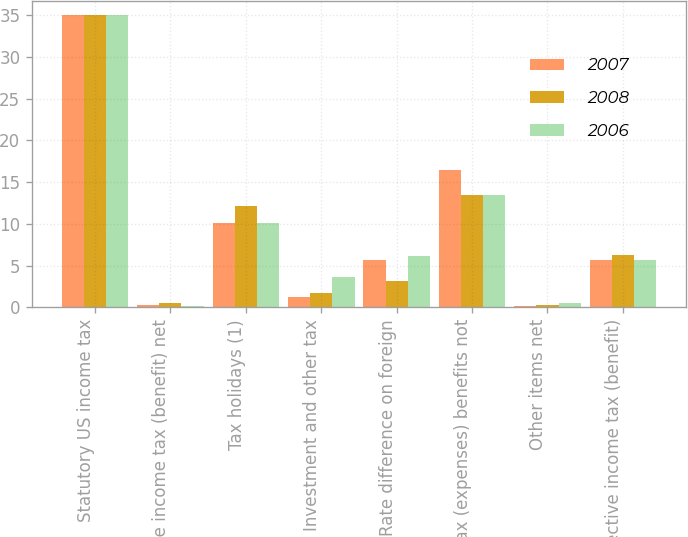Convert chart. <chart><loc_0><loc_0><loc_500><loc_500><stacked_bar_chart><ecel><fcel>Statutory US income tax<fcel>State income tax (benefit) net<fcel>Tax holidays (1)<fcel>Investment and other tax<fcel>Rate difference on foreign<fcel>Tax (expenses) benefits not<fcel>Other items net<fcel>Effective income tax (benefit)<nl><fcel>2007<fcel>35<fcel>0.3<fcel>10.1<fcel>1.2<fcel>5.7<fcel>16.5<fcel>0.1<fcel>5.7<nl><fcel>2008<fcel>35<fcel>0.5<fcel>12.1<fcel>1.7<fcel>3.1<fcel>13.5<fcel>0.3<fcel>6.2<nl><fcel>2006<fcel>35<fcel>0.2<fcel>10.1<fcel>3.6<fcel>6.1<fcel>13.4<fcel>0.5<fcel>5.7<nl></chart> 